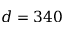Convert formula to latex. <formula><loc_0><loc_0><loc_500><loc_500>d = 3 4 0</formula> 